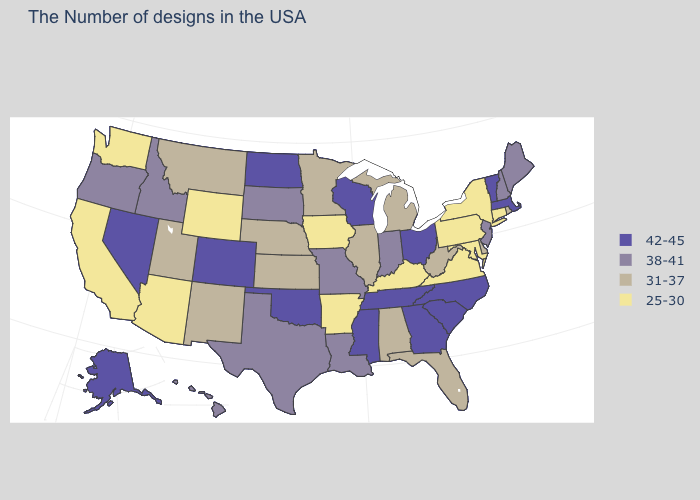Name the states that have a value in the range 25-30?
Short answer required. Connecticut, New York, Maryland, Pennsylvania, Virginia, Kentucky, Arkansas, Iowa, Wyoming, Arizona, California, Washington. Name the states that have a value in the range 25-30?
Short answer required. Connecticut, New York, Maryland, Pennsylvania, Virginia, Kentucky, Arkansas, Iowa, Wyoming, Arizona, California, Washington. What is the value of Connecticut?
Concise answer only. 25-30. Does Louisiana have the highest value in the USA?
Concise answer only. No. Name the states that have a value in the range 25-30?
Concise answer only. Connecticut, New York, Maryland, Pennsylvania, Virginia, Kentucky, Arkansas, Iowa, Wyoming, Arizona, California, Washington. Among the states that border Florida , does Alabama have the highest value?
Give a very brief answer. No. Is the legend a continuous bar?
Keep it brief. No. Among the states that border Illinois , which have the lowest value?
Keep it brief. Kentucky, Iowa. Name the states that have a value in the range 31-37?
Short answer required. Rhode Island, Delaware, West Virginia, Florida, Michigan, Alabama, Illinois, Minnesota, Kansas, Nebraska, New Mexico, Utah, Montana. Name the states that have a value in the range 25-30?
Keep it brief. Connecticut, New York, Maryland, Pennsylvania, Virginia, Kentucky, Arkansas, Iowa, Wyoming, Arizona, California, Washington. Among the states that border Nevada , does Oregon have the lowest value?
Quick response, please. No. What is the value of Indiana?
Write a very short answer. 38-41. Which states have the highest value in the USA?
Be succinct. Massachusetts, Vermont, North Carolina, South Carolina, Ohio, Georgia, Tennessee, Wisconsin, Mississippi, Oklahoma, North Dakota, Colorado, Nevada, Alaska. What is the value of Nebraska?
Quick response, please. 31-37. What is the value of California?
Give a very brief answer. 25-30. 